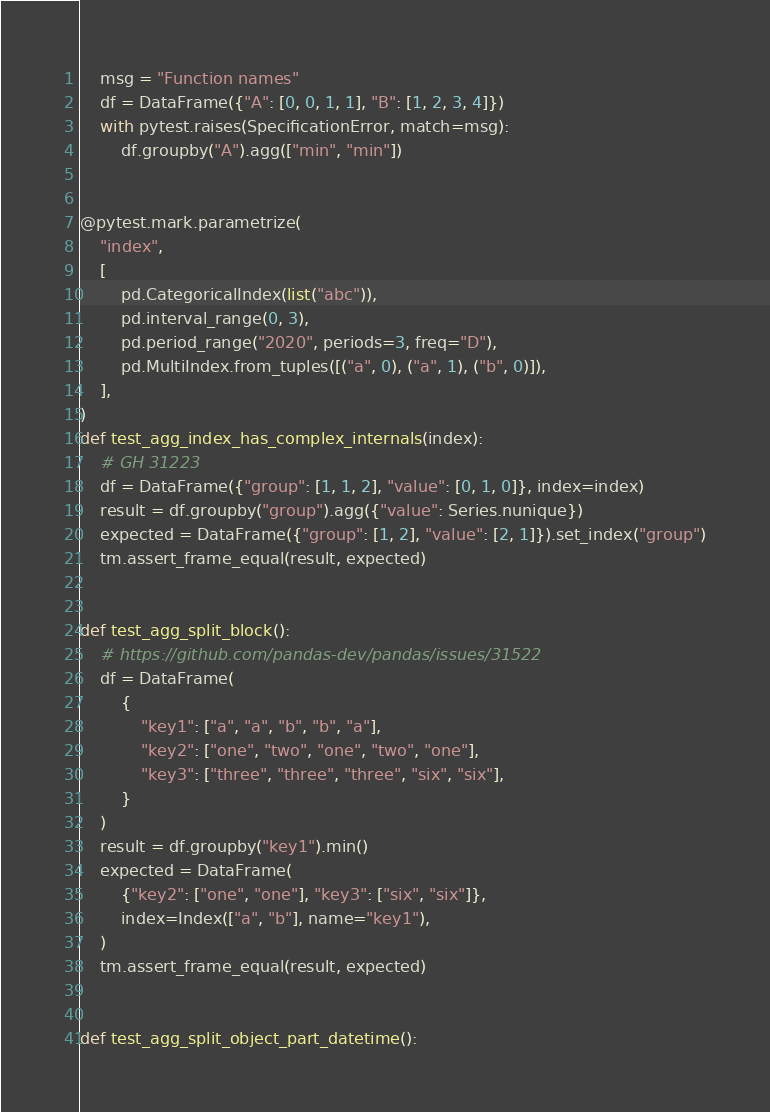<code> <loc_0><loc_0><loc_500><loc_500><_Python_>    msg = "Function names"
    df = DataFrame({"A": [0, 0, 1, 1], "B": [1, 2, 3, 4]})
    with pytest.raises(SpecificationError, match=msg):
        df.groupby("A").agg(["min", "min"])


@pytest.mark.parametrize(
    "index",
    [
        pd.CategoricalIndex(list("abc")),
        pd.interval_range(0, 3),
        pd.period_range("2020", periods=3, freq="D"),
        pd.MultiIndex.from_tuples([("a", 0), ("a", 1), ("b", 0)]),
    ],
)
def test_agg_index_has_complex_internals(index):
    # GH 31223
    df = DataFrame({"group": [1, 1, 2], "value": [0, 1, 0]}, index=index)
    result = df.groupby("group").agg({"value": Series.nunique})
    expected = DataFrame({"group": [1, 2], "value": [2, 1]}).set_index("group")
    tm.assert_frame_equal(result, expected)


def test_agg_split_block():
    # https://github.com/pandas-dev/pandas/issues/31522
    df = DataFrame(
        {
            "key1": ["a", "a", "b", "b", "a"],
            "key2": ["one", "two", "one", "two", "one"],
            "key3": ["three", "three", "three", "six", "six"],
        }
    )
    result = df.groupby("key1").min()
    expected = DataFrame(
        {"key2": ["one", "one"], "key3": ["six", "six"]},
        index=Index(["a", "b"], name="key1"),
    )
    tm.assert_frame_equal(result, expected)


def test_agg_split_object_part_datetime():</code> 